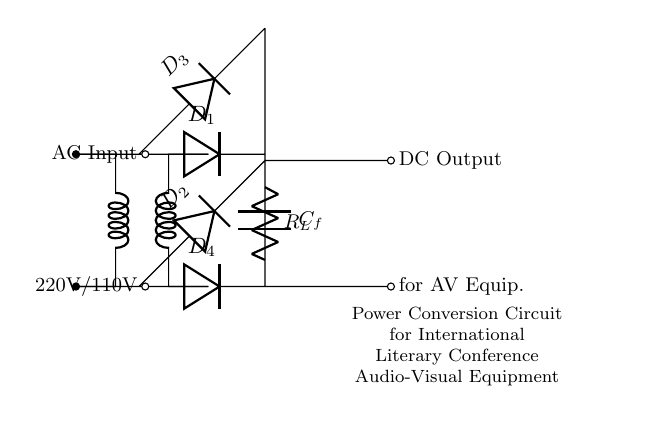What type of circuit is this? This circuit diagram represents a rectifier circuit, which is designed to convert alternating current (AC) to direct current (DC). This functionality is indicated by the presence of diodes and the resulting DC output.
Answer: Rectifier How many diodes are used in this circuit? The circuit includes four diodes labeled D1, D2, D3, and D4. They are connected in a configuration that allows them to rectify the AC voltage into a DC voltage. Counting them visually confirms the number.
Answer: Four What is the input voltage rating of the circuit? The circuit specifies an input voltage of either 220V or 110V, as shown in the labels at the input terminals. These values are common AC supply voltages.
Answer: 220V/110V What component is used for filtering in the circuit? The circuit employs a capacitor, denoted as C_f, which is used to smooth out the rectified output and reduce ripples, thus providing a more stable DC voltage. This filtering action is crucial for the performance of the AV equipment.
Answer: Capacitor What is the purpose of the resistor labeled R_L? The resistor R_L serves as the load for the circuit. It is connected to the DC output to simulate the load that the audio-visual equipment will draw power from. This exemplifies the operational condition of the circuit and how it interacts with connected devices.
Answer: Load What is the output of this circuit indicated as? The output of the circuit is labeled as "DC Output" specifically noted for "AV Equip.", indicating that the converted DC power is intended for audio-visual equipment used in the conference. This specifies the function of the circuit clearly.
Answer: DC Output for AV Equip 